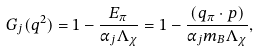Convert formula to latex. <formula><loc_0><loc_0><loc_500><loc_500>G _ { j } ( q ^ { 2 } ) = 1 - \frac { E _ { \pi } } { \alpha _ { j } \Lambda _ { \chi } } = 1 - \frac { ( q _ { \pi } \cdot p ) } { \alpha _ { j } m _ { B } \Lambda _ { \chi } } ,</formula> 